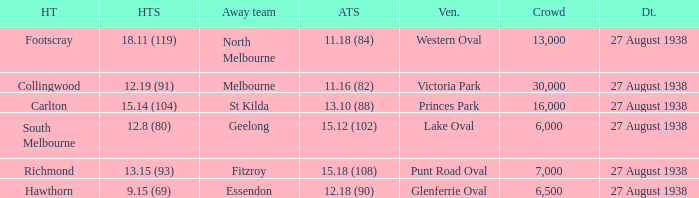Which Team plays at Western Oval? Footscray. 